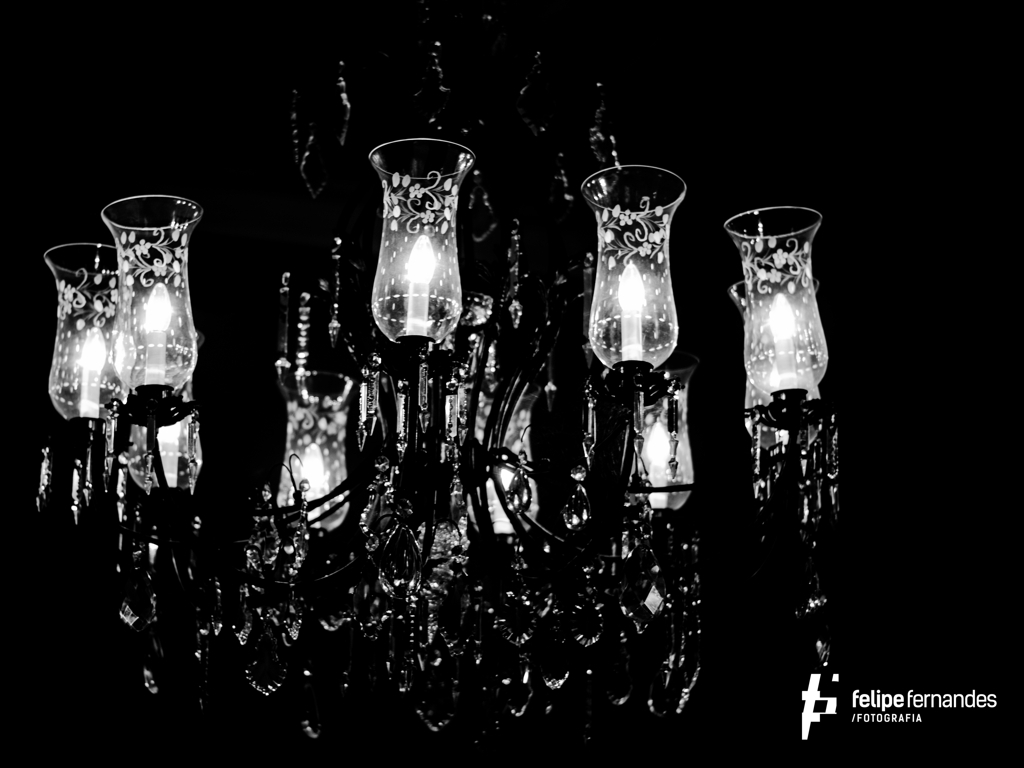Can you describe the lighting in this photo and its impact on the atmosphere? The lighting in this photo is soft and directed, emanating from the chandelier bulbs, creating an intimate and serene atmosphere. It highlights the finer details and patterns on the glass, contributing to the luxurious and sophisticated feel of the scene. 